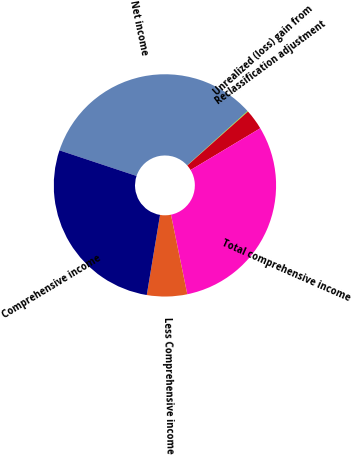Convert chart. <chart><loc_0><loc_0><loc_500><loc_500><pie_chart><fcel>Net income<fcel>Unrealized (loss) gain from<fcel>Reclassification adjustment<fcel>Total comprehensive income<fcel>Less Comprehensive income<fcel>Comprehensive income<nl><fcel>33.24%<fcel>0.09%<fcel>2.97%<fcel>30.37%<fcel>5.84%<fcel>27.49%<nl></chart> 